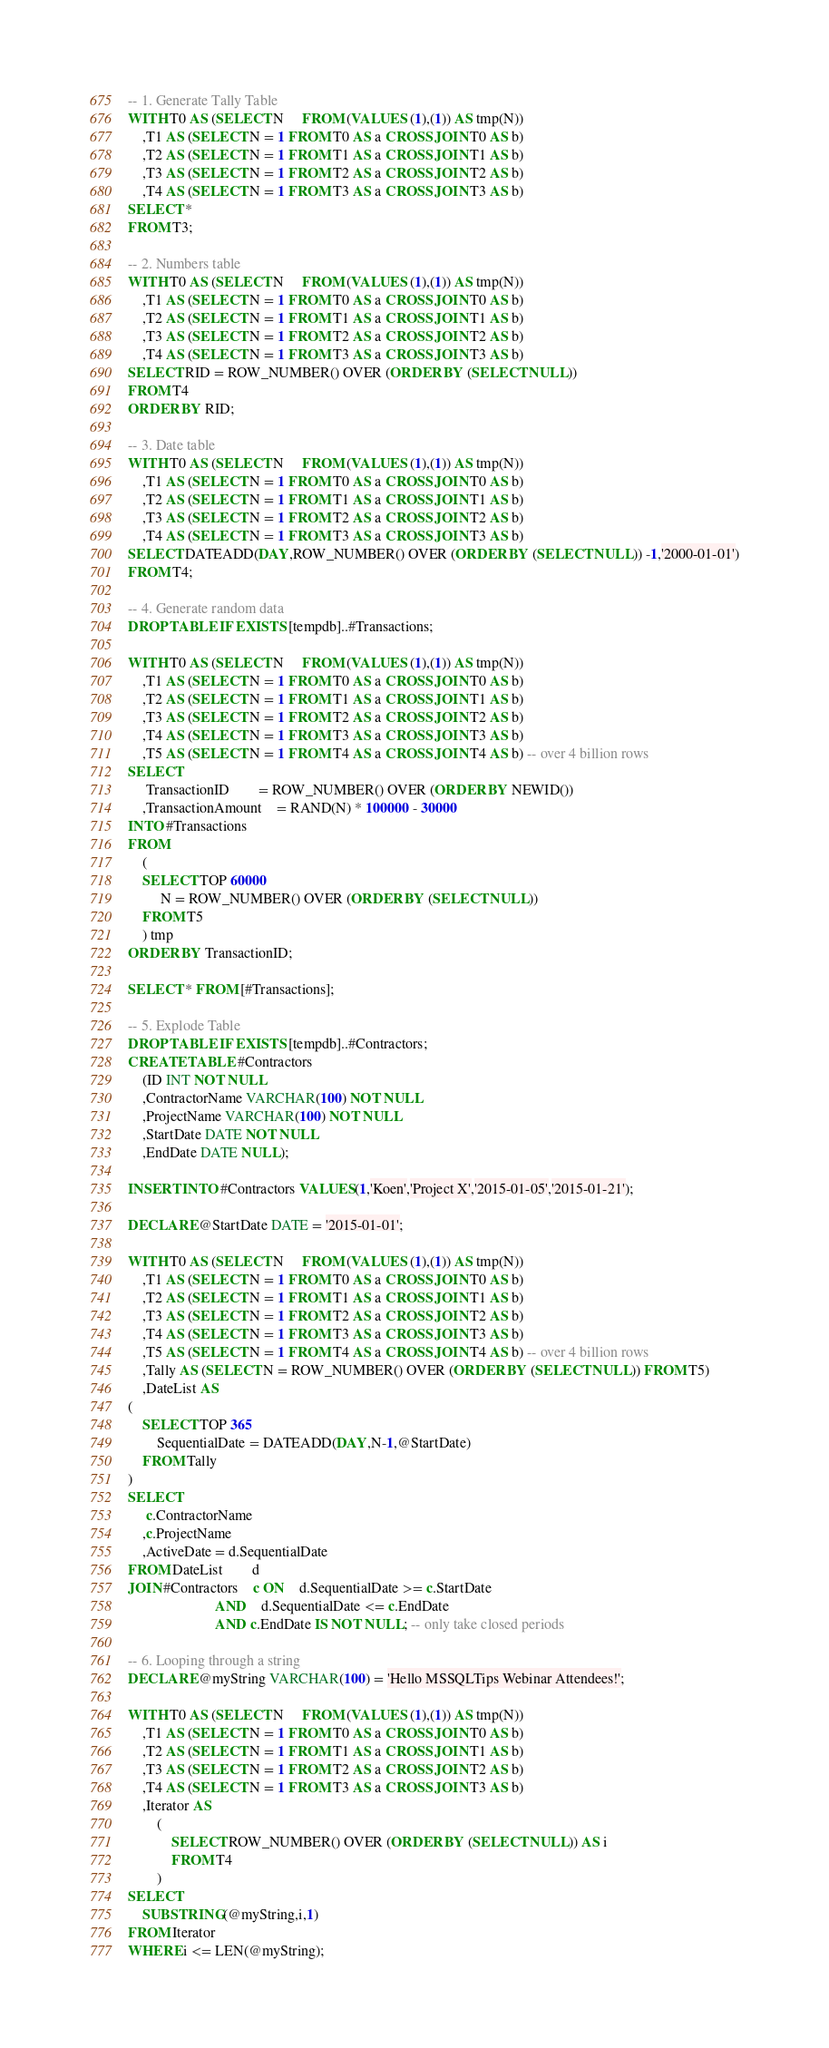Convert code to text. <code><loc_0><loc_0><loc_500><loc_500><_SQL_>-- 1. Generate Tally Table
WITH T0 AS (SELECT N	 FROM (VALUES (1),(1)) AS tmp(N))
	,T1 AS (SELECT N = 1 FROM T0 AS a CROSS JOIN T0 AS b)
	,T2 AS (SELECT N = 1 FROM T1 AS a CROSS JOIN T1 AS b)
	,T3 AS (SELECT N = 1 FROM T2 AS a CROSS JOIN T2 AS b)
	,T4 AS (SELECT N = 1 FROM T3 AS a CROSS JOIN T3 AS b)
SELECT *
FROM T3;

-- 2. Numbers table
WITH T0 AS (SELECT N	 FROM (VALUES (1),(1)) AS tmp(N))
	,T1 AS (SELECT N = 1 FROM T0 AS a CROSS JOIN T0 AS b)
	,T2 AS (SELECT N = 1 FROM T1 AS a CROSS JOIN T1 AS b)
	,T3 AS (SELECT N = 1 FROM T2 AS a CROSS JOIN T2 AS b)
	,T4 AS (SELECT N = 1 FROM T3 AS a CROSS JOIN T3 AS b)
SELECT RID = ROW_NUMBER() OVER (ORDER BY (SELECT NULL))
FROM T4
ORDER BY RID;

-- 3. Date table
WITH T0 AS (SELECT N	 FROM (VALUES (1),(1)) AS tmp(N))
	,T1 AS (SELECT N = 1 FROM T0 AS a CROSS JOIN T0 AS b)
	,T2 AS (SELECT N = 1 FROM T1 AS a CROSS JOIN T1 AS b)
	,T3 AS (SELECT N = 1 FROM T2 AS a CROSS JOIN T2 AS b)
	,T4 AS (SELECT N = 1 FROM T3 AS a CROSS JOIN T3 AS b)
SELECT DATEADD(DAY,ROW_NUMBER() OVER (ORDER BY (SELECT NULL)) -1,'2000-01-01')
FROM T4;

-- 4. Generate random data
DROP TABLE IF EXISTS [tempdb]..#Transactions;

WITH T0 AS (SELECT N	 FROM (VALUES (1),(1)) AS tmp(N))
	,T1 AS (SELECT N = 1 FROM T0 AS a CROSS JOIN T0 AS b)
	,T2 AS (SELECT N = 1 FROM T1 AS a CROSS JOIN T1 AS b)
	,T3 AS (SELECT N = 1 FROM T2 AS a CROSS JOIN T2 AS b)
	,T4 AS (SELECT N = 1 FROM T3 AS a CROSS JOIN T3 AS b)
	,T5 AS (SELECT N = 1 FROM T4 AS a CROSS JOIN T4 AS b) -- over 4 billion rows
SELECT
	 TransactionID		= ROW_NUMBER() OVER (ORDER BY NEWID())
	,TransactionAmount	= RAND(N) * 100000 - 30000
INTO #Transactions
FROM
	(
	SELECT TOP 60000
		 N = ROW_NUMBER() OVER (ORDER BY (SELECT NULL))
	FROM T5
	) tmp
ORDER BY TransactionID;

SELECT * FROM [#Transactions];

-- 5. Explode Table
DROP TABLE IF EXISTS [tempdb]..#Contractors;
CREATE TABLE #Contractors
	(ID INT NOT NULL
	,ContractorName VARCHAR(100) NOT NULL
	,ProjectName VARCHAR(100) NOT NULL
	,StartDate DATE NOT NULL
	,EndDate DATE NULL);

INSERT INTO #Contractors VALUES(1,'Koen','Project X','2015-01-05','2015-01-21');

DECLARE @StartDate DATE = '2015-01-01';

WITH T0 AS (SELECT N	 FROM (VALUES (1),(1)) AS tmp(N))
	,T1 AS (SELECT N = 1 FROM T0 AS a CROSS JOIN T0 AS b)
	,T2 AS (SELECT N = 1 FROM T1 AS a CROSS JOIN T1 AS b)
	,T3 AS (SELECT N = 1 FROM T2 AS a CROSS JOIN T2 AS b)
	,T4 AS (SELECT N = 1 FROM T3 AS a CROSS JOIN T3 AS b)
	,T5 AS (SELECT N = 1 FROM T4 AS a CROSS JOIN T4 AS b) -- over 4 billion rows
	,Tally AS (SELECT N = ROW_NUMBER() OVER (ORDER BY (SELECT NULL)) FROM T5)
	,DateList AS
(
	SELECT TOP 365
		SequentialDate = DATEADD(DAY,N-1,@StartDate)
	FROM Tally
)
SELECT
	 c.ContractorName
	,c.ProjectName
	,ActiveDate = d.SequentialDate
FROM DateList		d
JOIN #Contractors	c ON	d.SequentialDate >= c.StartDate
						AND	d.SequentialDate <= c.EndDate
						AND c.EndDate IS NOT NULL; -- only take closed periods

-- 6. Looping through a string
DECLARE @myString VARCHAR(100) = 'Hello MSSQLTips Webinar Attendees!';

WITH T0 AS (SELECT N	 FROM (VALUES (1),(1)) AS tmp(N))
	,T1 AS (SELECT N = 1 FROM T0 AS a CROSS JOIN T0 AS b)
	,T2 AS (SELECT N = 1 FROM T1 AS a CROSS JOIN T1 AS b)
	,T3 AS (SELECT N = 1 FROM T2 AS a CROSS JOIN T2 AS b)
	,T4 AS (SELECT N = 1 FROM T3 AS a CROSS JOIN T3 AS b)
    ,Iterator AS
        (
            SELECT ROW_NUMBER() OVER (ORDER BY (SELECT NULL)) AS i
            FROM T4
        )
SELECT
    SUBSTRING(@myString,i,1)
FROM Iterator
WHERE i <= LEN(@myString);
</code> 